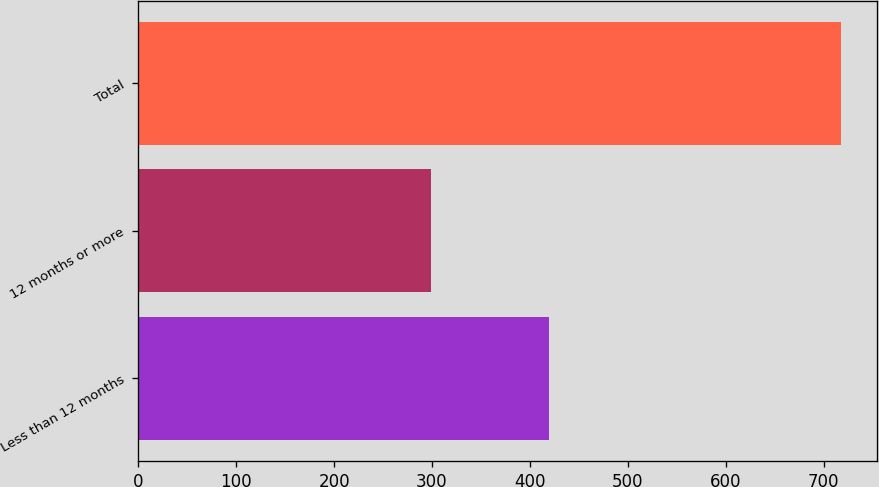Convert chart. <chart><loc_0><loc_0><loc_500><loc_500><bar_chart><fcel>Less than 12 months<fcel>12 months or more<fcel>Total<nl><fcel>419.6<fcel>298.6<fcel>718.2<nl></chart> 